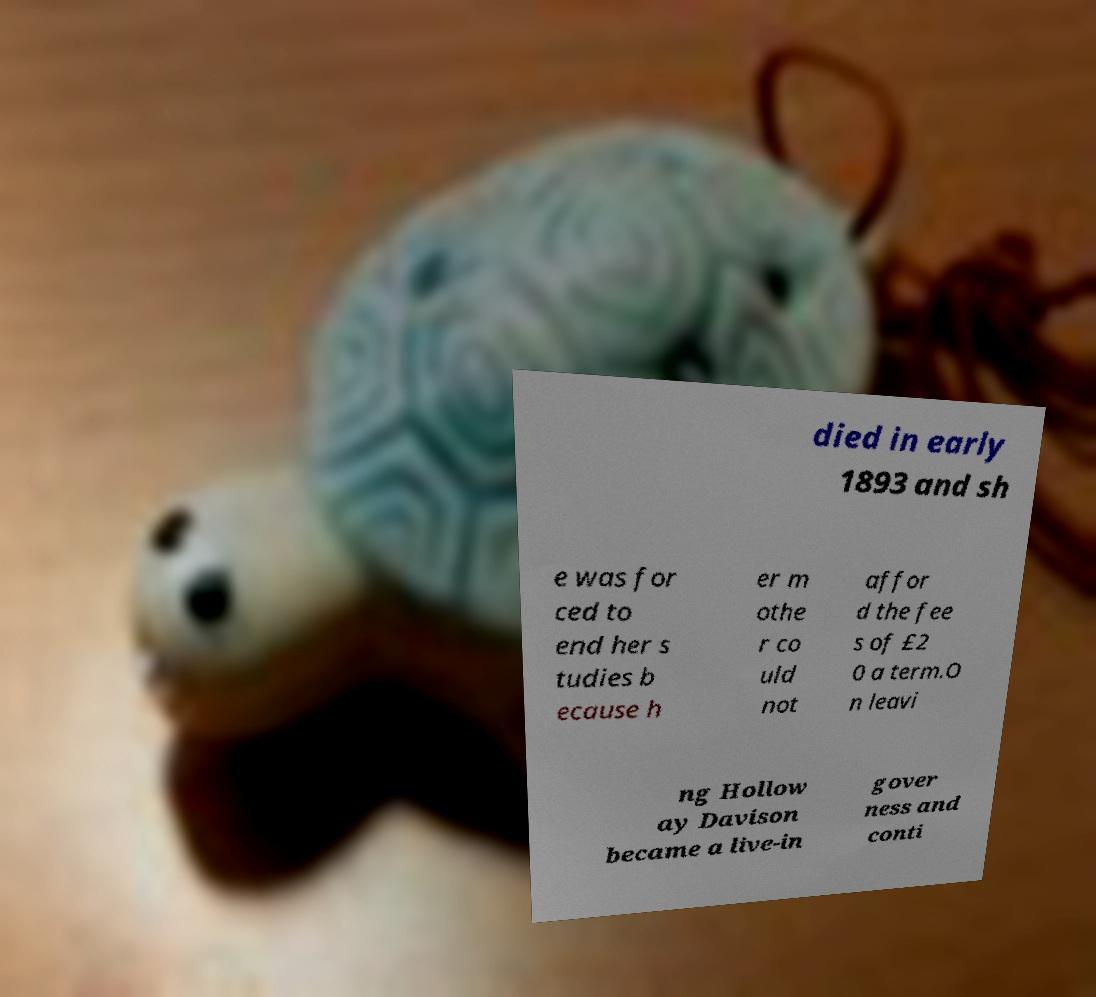Can you accurately transcribe the text from the provided image for me? died in early 1893 and sh e was for ced to end her s tudies b ecause h er m othe r co uld not affor d the fee s of £2 0 a term.O n leavi ng Hollow ay Davison became a live-in gover ness and conti 